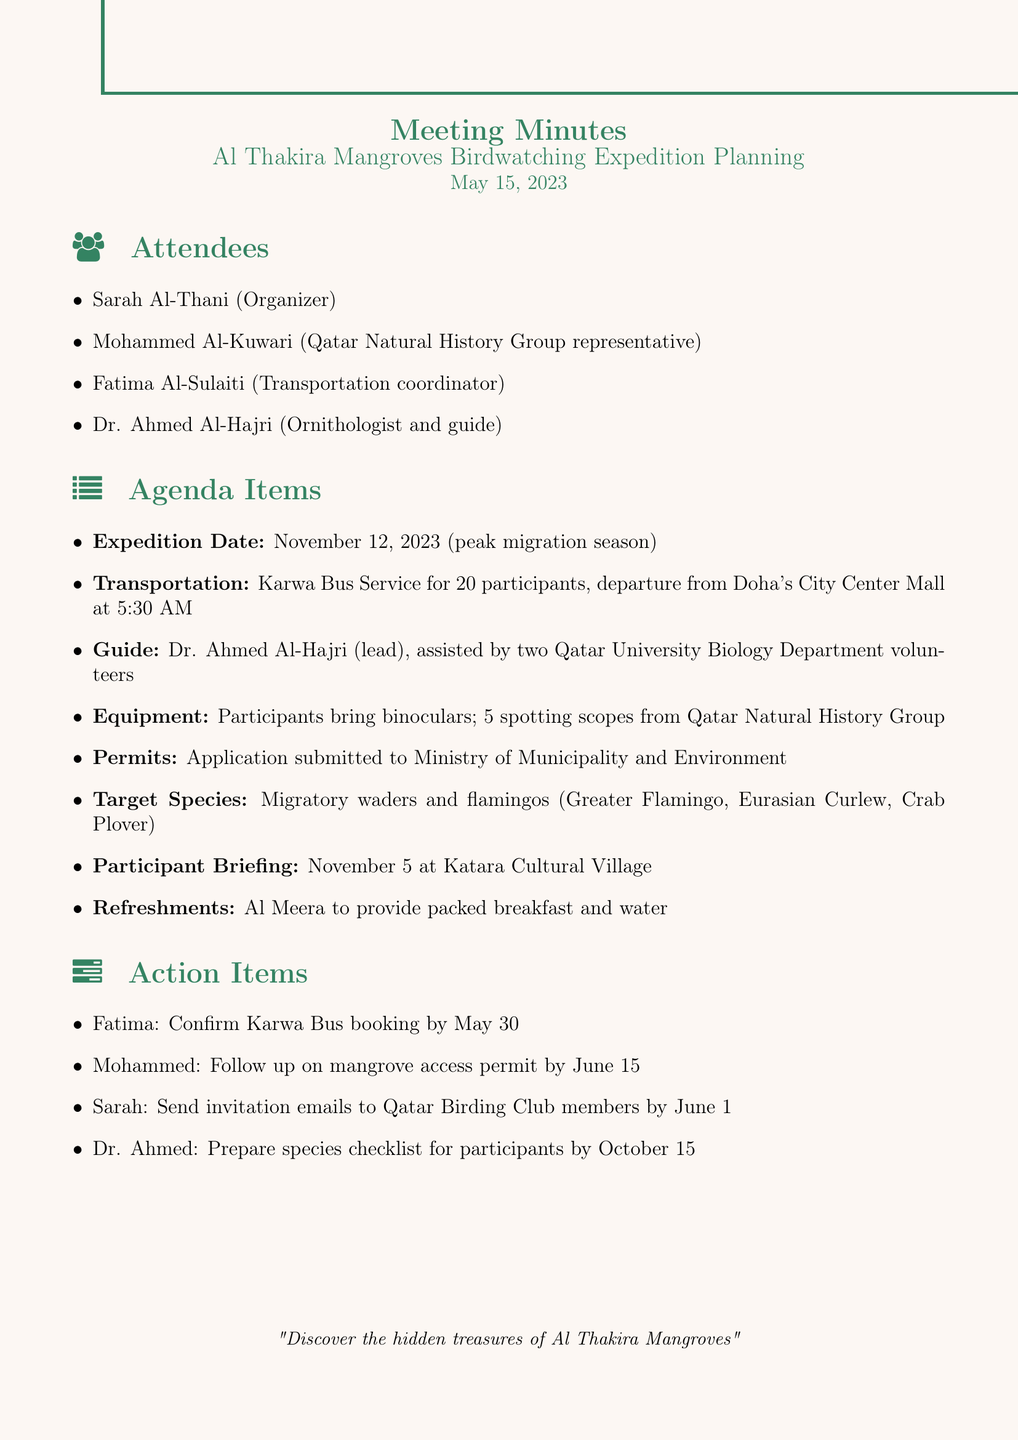what is the meeting title? The meeting title is explicitly mentioned at the beginning of the document.
Answer: Al Thakira Mangroves Birdwatching Expedition Planning who is the organizer of the expedition? The organizer is listed among the attendees in the document.
Answer: Sarah Al-Thani when is the proposed expedition date? The proposed date is specified under the agenda items section of the document.
Answer: November 12, 2023 how many participants is the transportation arranged for? The number of participants for the Karwa Bus Service is indicated in the transportation arrangements item.
Answer: 20 participants who will lead the birdwatching expedition? The lead guide is mentioned in the guide arrangements section of the document.
Answer: Dr. Ahmed Al-Hajri what is the main focus of the birdwatching expedition? The target species are explicitly listed in the agenda items section of the document.
Answer: Migratory waders and flamingos when is the participant briefing scheduled? The date of the participant briefing is noted in the agenda items section.
Answer: November 5 what is Fatima's action item due date? The action items section lists the due date for Fatima's task.
Answer: May 30 which company is providing refreshments? The refreshments provider is named in the agenda items section of the document.
Answer: Al Meera 